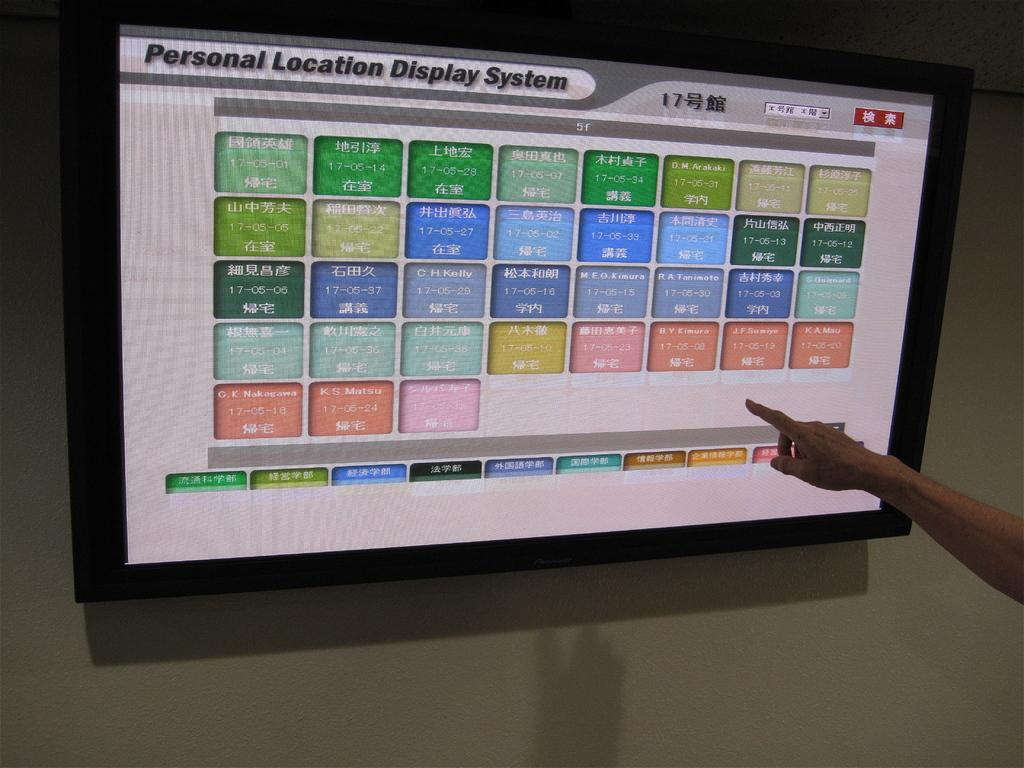<image>
Summarize the visual content of the image. tv screen is turned on with the location display system on the screen 